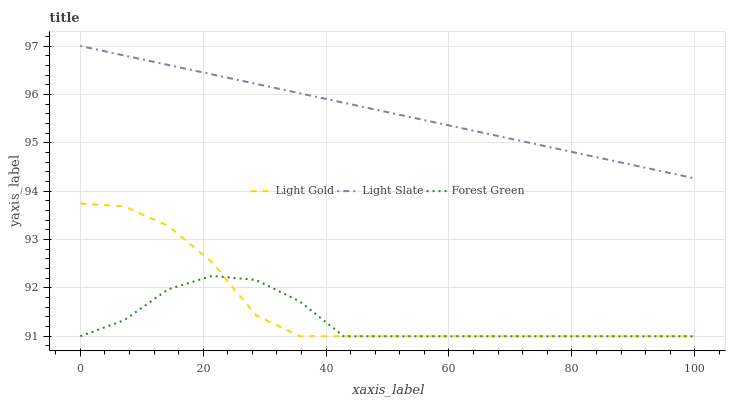Does Forest Green have the minimum area under the curve?
Answer yes or no. Yes. Does Light Slate have the maximum area under the curve?
Answer yes or no. Yes. Does Light Gold have the minimum area under the curve?
Answer yes or no. No. Does Light Gold have the maximum area under the curve?
Answer yes or no. No. Is Light Slate the smoothest?
Answer yes or no. Yes. Is Forest Green the roughest?
Answer yes or no. Yes. Is Light Gold the smoothest?
Answer yes or no. No. Is Light Gold the roughest?
Answer yes or no. No. Does Forest Green have the lowest value?
Answer yes or no. Yes. Does Light Slate have the highest value?
Answer yes or no. Yes. Does Light Gold have the highest value?
Answer yes or no. No. Is Forest Green less than Light Slate?
Answer yes or no. Yes. Is Light Slate greater than Light Gold?
Answer yes or no. Yes. Does Light Gold intersect Forest Green?
Answer yes or no. Yes. Is Light Gold less than Forest Green?
Answer yes or no. No. Is Light Gold greater than Forest Green?
Answer yes or no. No. Does Forest Green intersect Light Slate?
Answer yes or no. No. 